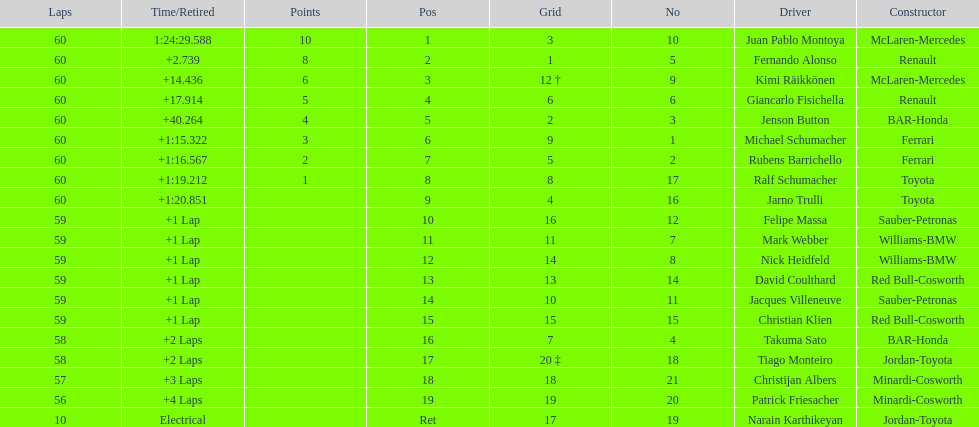What is the number of toyota's on the list? 4. 